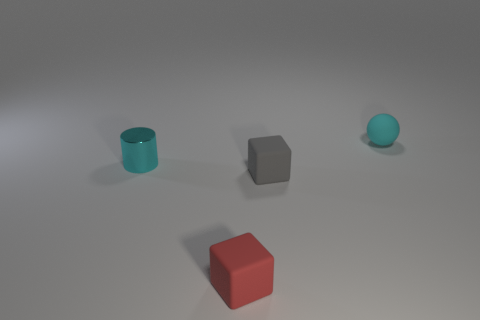Are there more cubes than tiny cyan metal cylinders?
Offer a terse response. Yes. How many rubber things are on the left side of the tiny matte object behind the tiny cylinder?
Make the answer very short. 2. There is a tiny matte ball; are there any tiny matte objects left of it?
Ensure brevity in your answer.  Yes. There is a cyan thing that is behind the cyan object left of the cyan rubber object; what is its shape?
Offer a terse response. Sphere. Are there fewer small gray things that are to the left of the tiny cyan metal cylinder than small red blocks in front of the ball?
Give a very brief answer. Yes. There is another small matte thing that is the same shape as the gray thing; what is its color?
Your answer should be compact. Red. What number of small objects are both behind the small metallic thing and in front of the shiny thing?
Your response must be concise. 0. Is the number of cyan metal things to the right of the tiny sphere greater than the number of things that are right of the tiny gray matte object?
Your answer should be compact. No. The red cube has what size?
Provide a short and direct response. Small. Are there any red rubber things of the same shape as the small cyan matte thing?
Provide a short and direct response. No. 